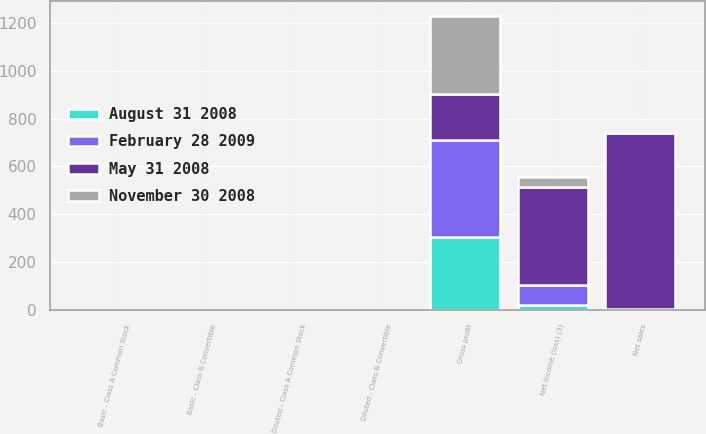Convert chart. <chart><loc_0><loc_0><loc_500><loc_500><stacked_bar_chart><ecel><fcel>Net sales<fcel>Gross profit<fcel>Net income (loss) (3)<fcel>Basic - Class A Common Stock<fcel>Basic - Class B Convertible<fcel>Diluted - Class A Common Stock<fcel>Diluted - Class B Convertible<nl><fcel>November 30 2008<fcel>1.71<fcel>329<fcel>44.6<fcel>0.21<fcel>0.19<fcel>0.2<fcel>0.19<nl><fcel>August 31 2008<fcel>1.71<fcel>305.8<fcel>22.7<fcel>0.11<fcel>0.1<fcel>0.11<fcel>0.1<nl><fcel>February 28 2009<fcel>1.71<fcel>404<fcel>83.5<fcel>0.39<fcel>0.35<fcel>0.38<fcel>0.35<nl><fcel>May 31 2008<fcel>735.1<fcel>191.2<fcel>406.8<fcel>1.88<fcel>1.71<fcel>1.88<fcel>1.71<nl></chart> 